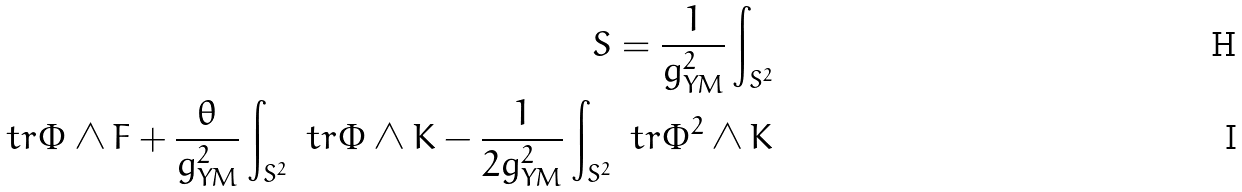<formula> <loc_0><loc_0><loc_500><loc_500>S = \frac { 1 } { g _ { Y M } ^ { 2 } } \int _ { S ^ { 2 } } \\ t r \Phi \wedge F + \frac { \theta } { g _ { Y M } ^ { 2 } } \int _ { S ^ { 2 } } \ t r \Phi \wedge K - \frac { 1 } { 2 g _ { Y M } ^ { 2 } } \int _ { S ^ { 2 } } \ t r \Phi ^ { 2 } \wedge K</formula> 